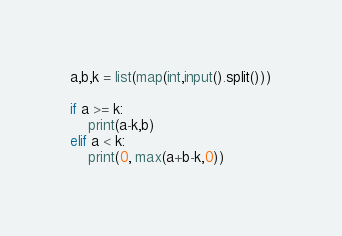Convert code to text. <code><loc_0><loc_0><loc_500><loc_500><_Python_>a,b,k = list(map(int,input().split()))

if a >= k:
    print(a-k,b)
elif a < k:
    print(0, max(a+b-k,0))


</code> 